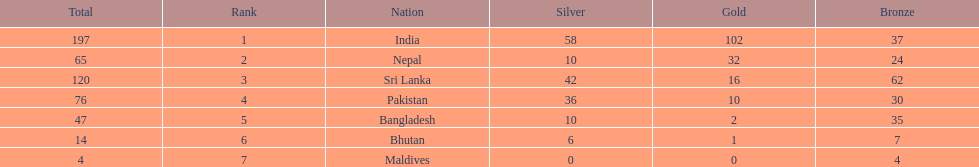How many countries have one more than 10 gold medals? 3. 